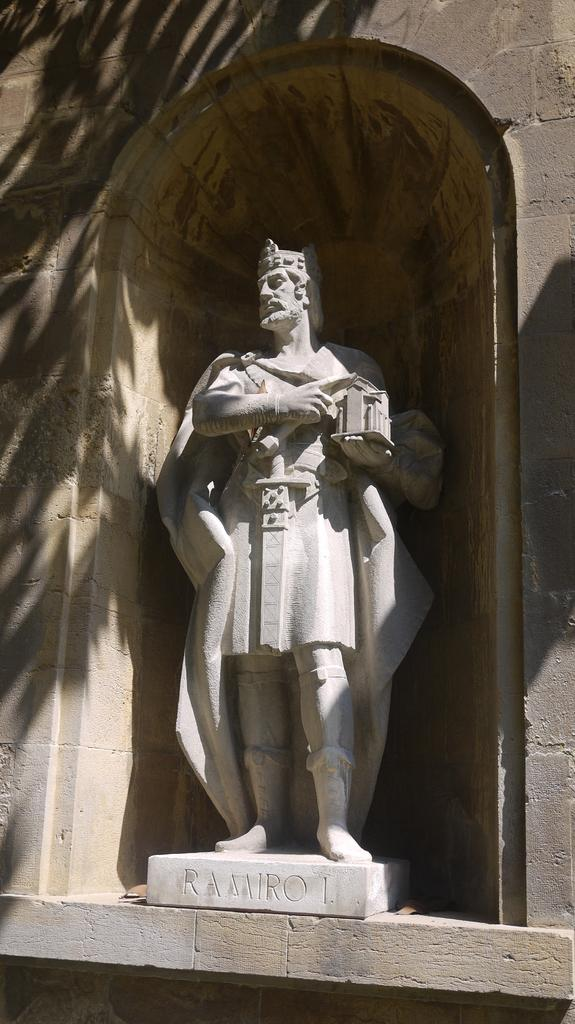What is the main subject of the image? There is a statue of a person in the image. Where is the statue located? The statue is present on a wall. What else can be seen in the image besides the statue? There are shadows of trees visible in the image. What type of brick is used to build the statue's stomach in the image? There is no brick or stomach present in the image, as the statue is not a real person but a representation made of a different material. 